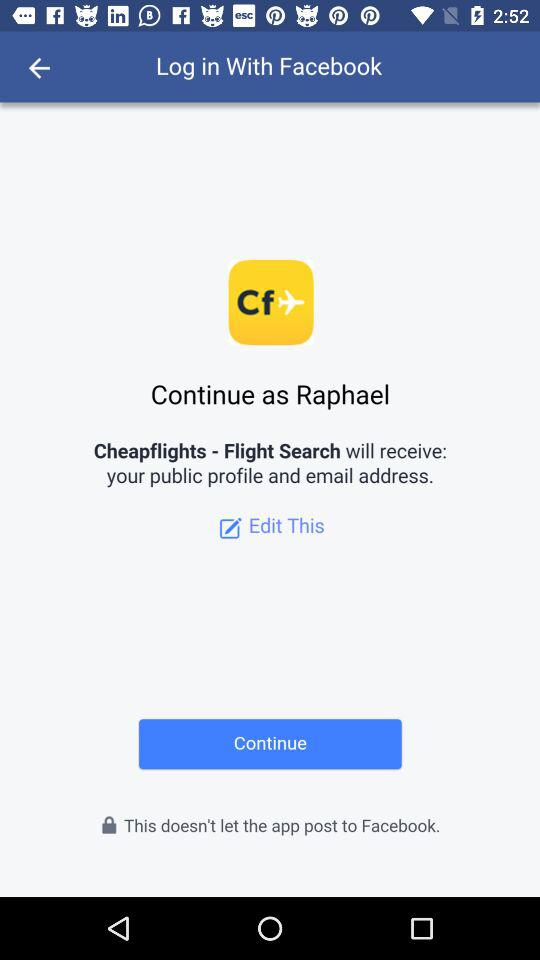What application will receive the public profile and email address? The application is "Cheapflights - Flight Search". 